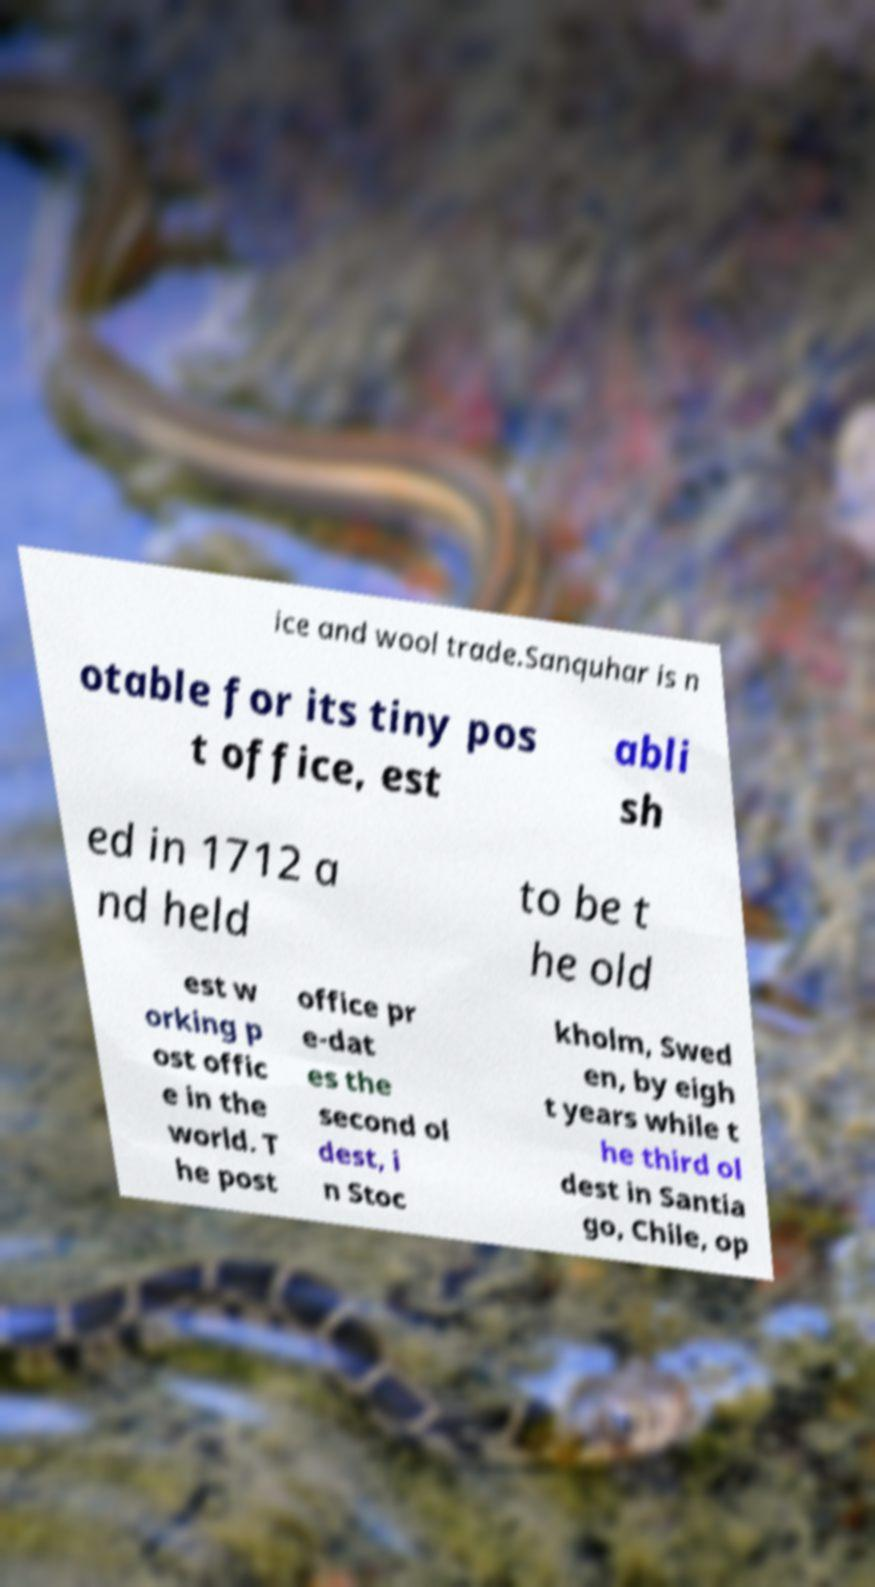Could you extract and type out the text from this image? ice and wool trade.Sanquhar is n otable for its tiny pos t office, est abli sh ed in 1712 a nd held to be t he old est w orking p ost offic e in the world. T he post office pr e-dat es the second ol dest, i n Stoc kholm, Swed en, by eigh t years while t he third ol dest in Santia go, Chile, op 